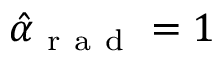<formula> <loc_0><loc_0><loc_500><loc_500>\hat { \alpha } _ { r a d } = 1</formula> 